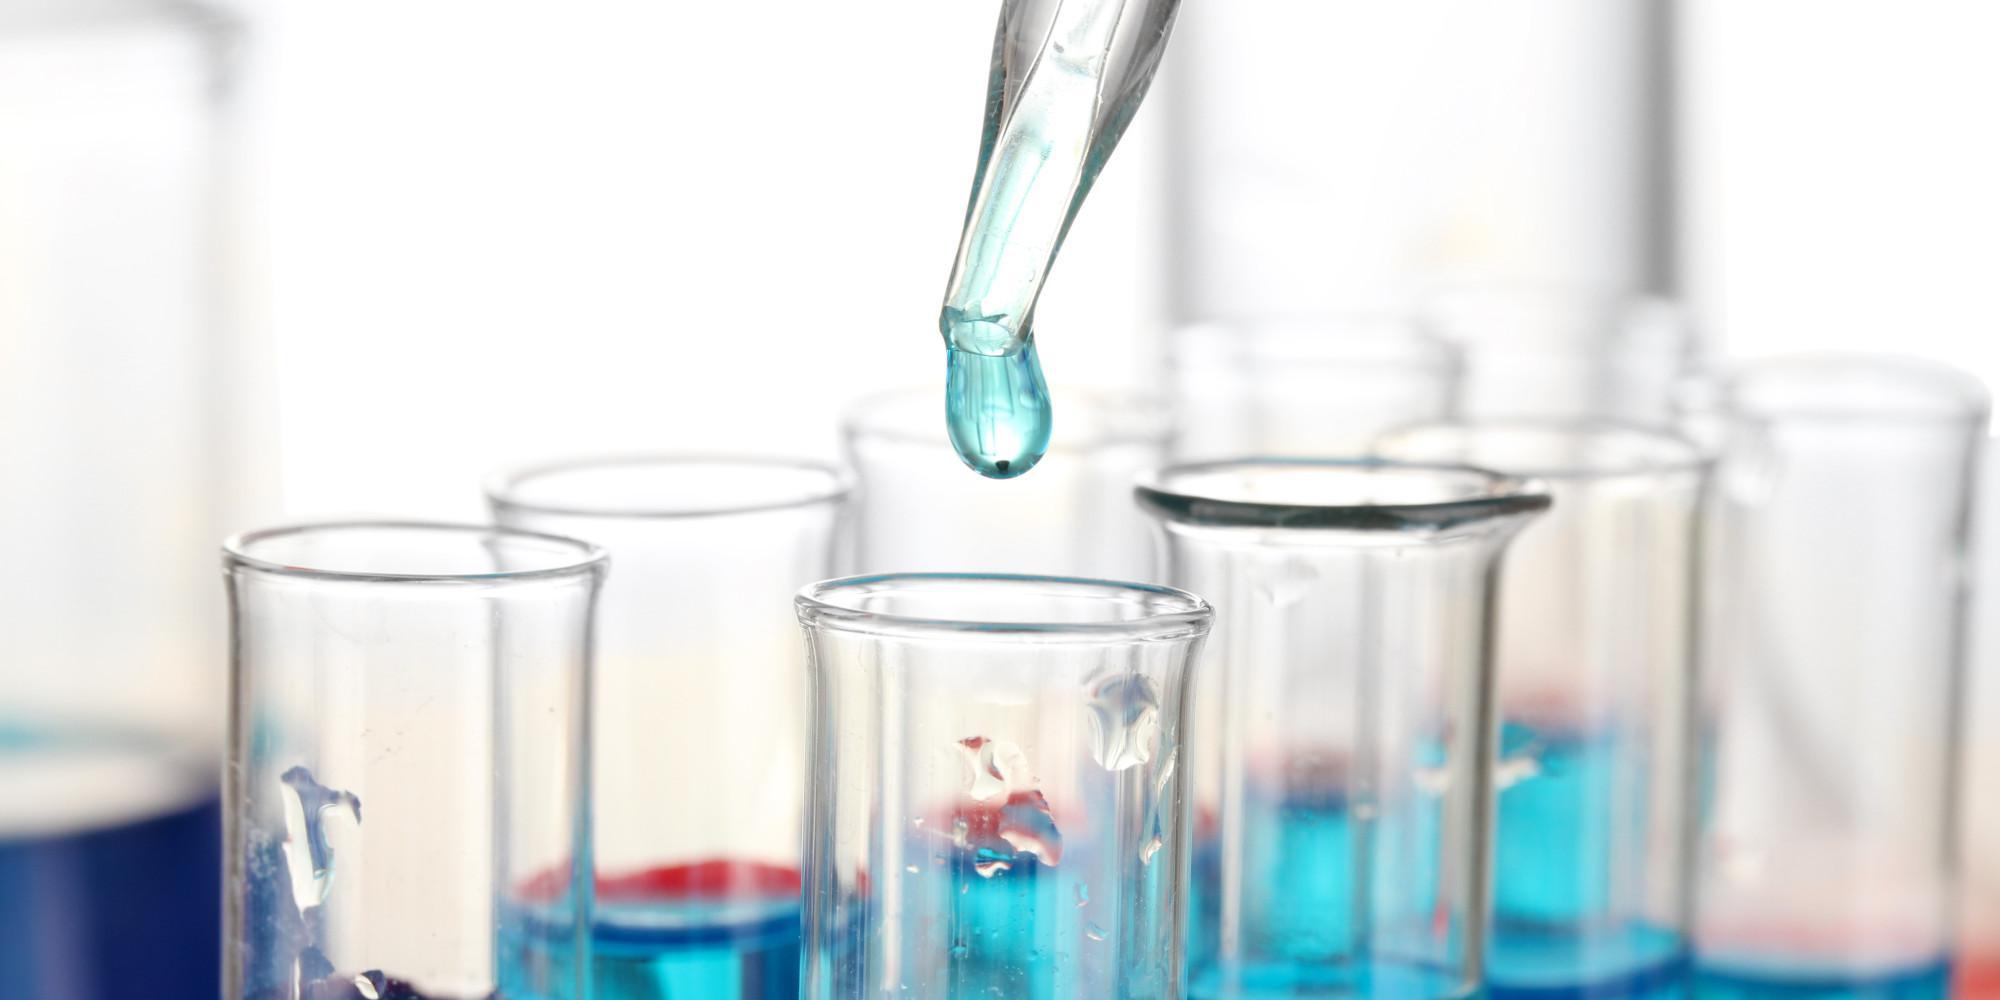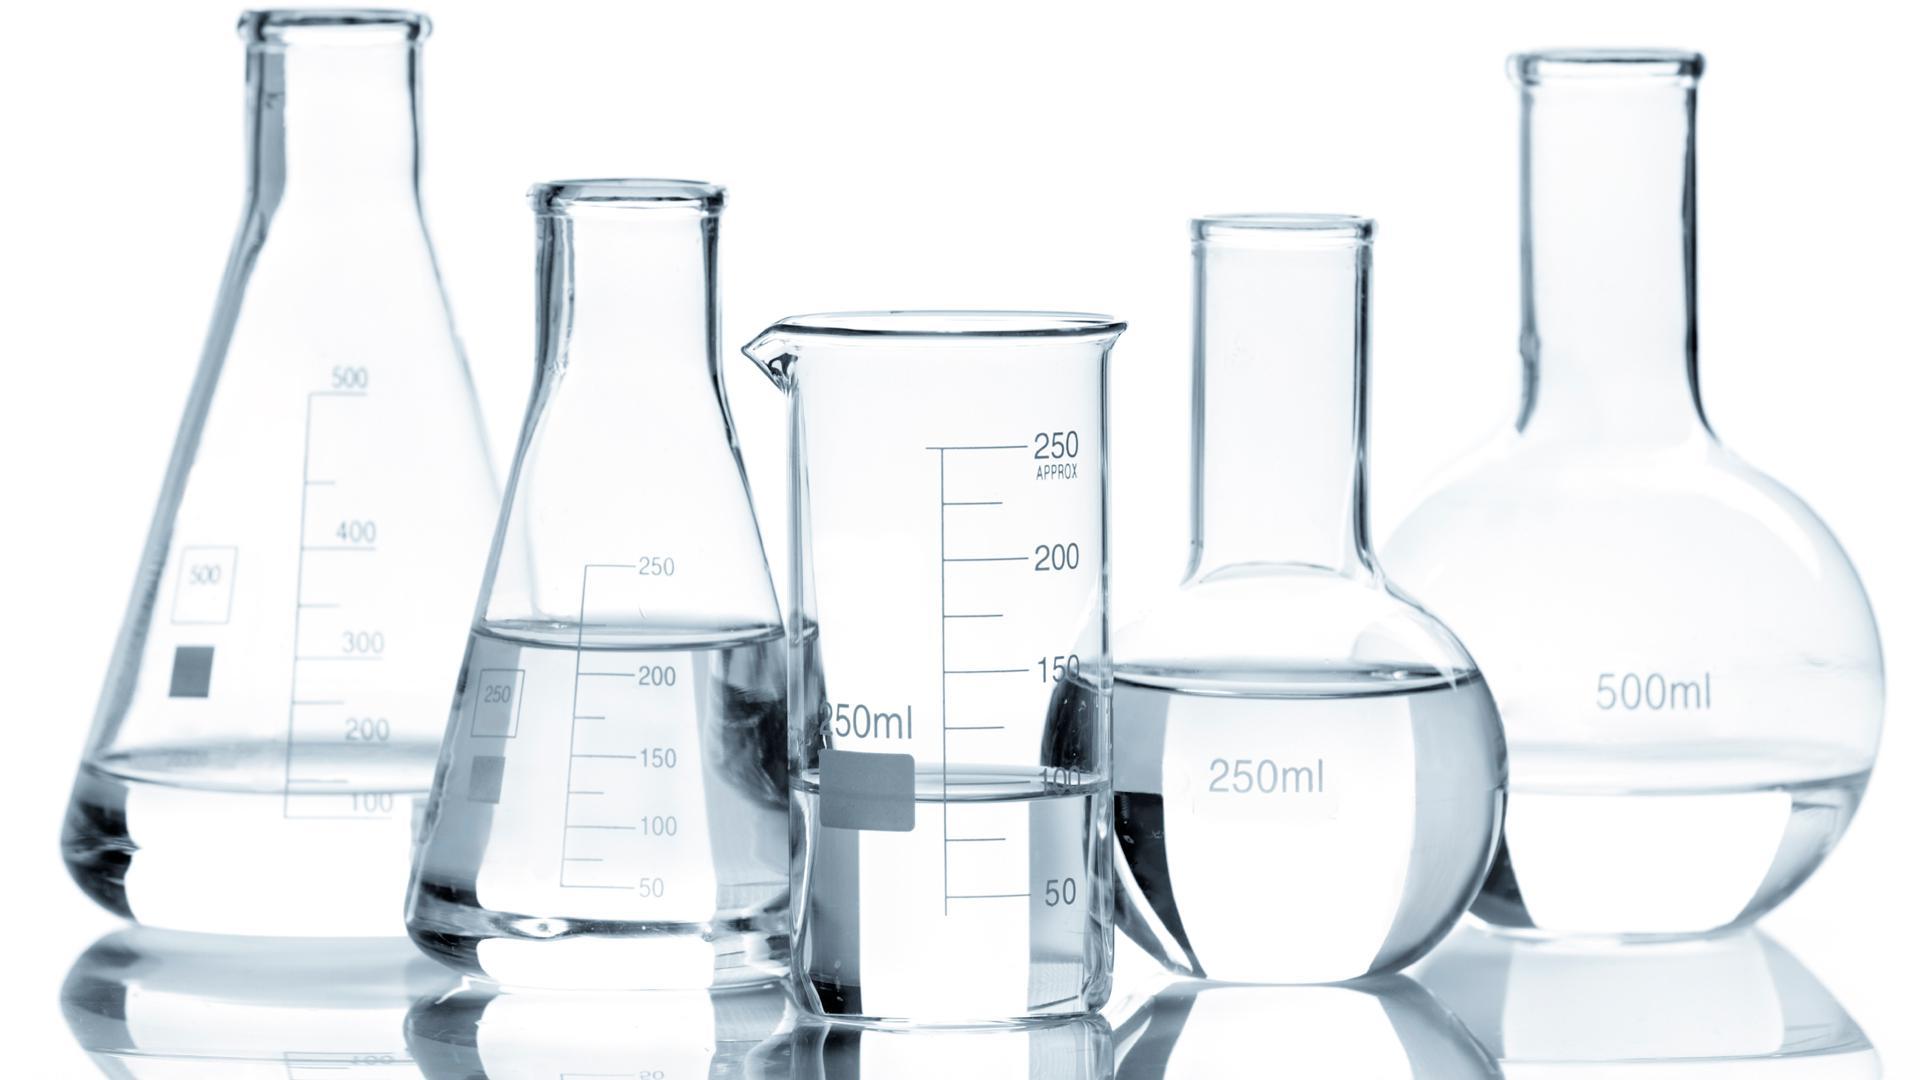The first image is the image on the left, the second image is the image on the right. For the images displayed, is the sentence "An image shows beakers containing multiple liquid colors, including red, yellow, and blue." factually correct? Answer yes or no. No. The first image is the image on the left, the second image is the image on the right. For the images displayed, is the sentence "There are at most 3 laboratory flasks in the left image." factually correct? Answer yes or no. No. 